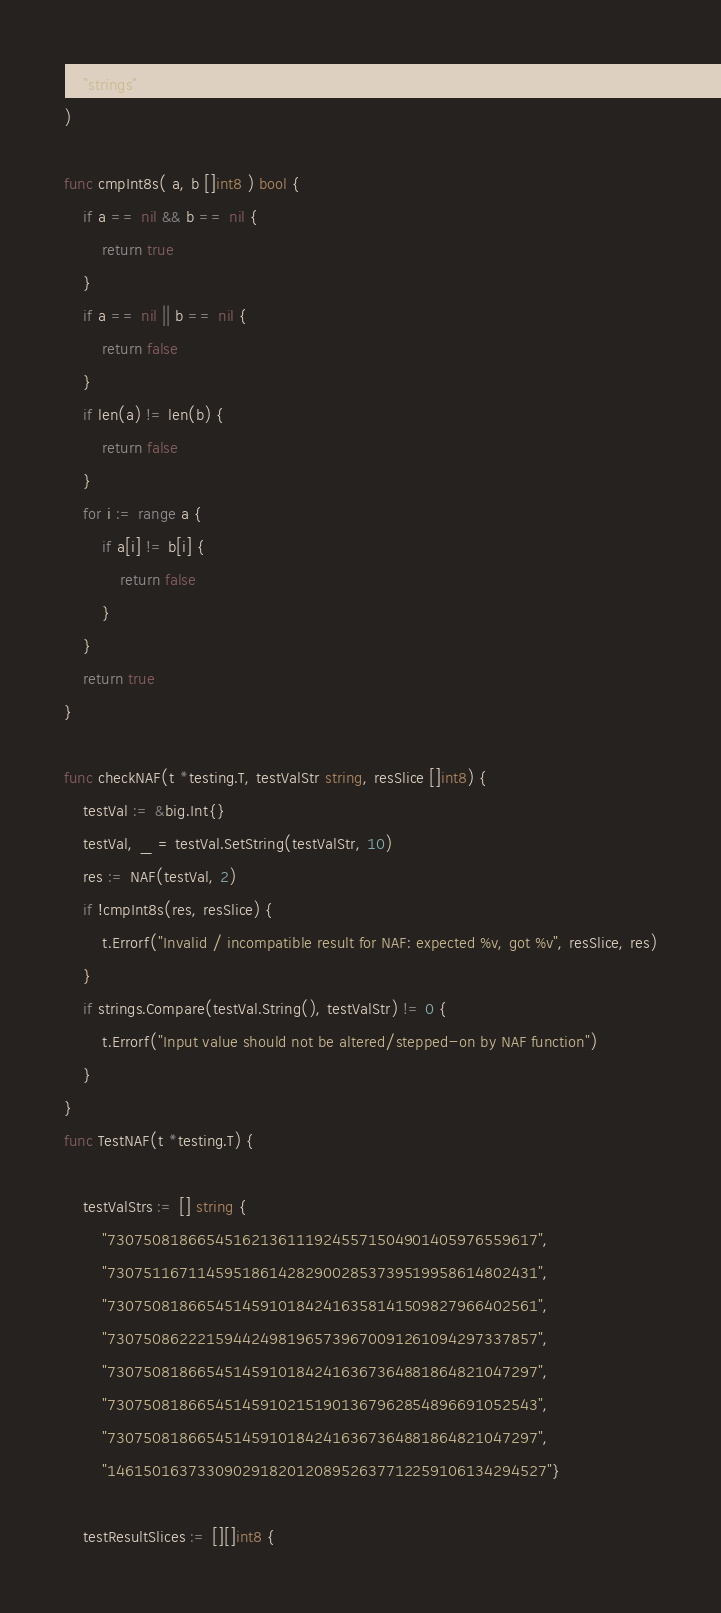Convert code to text. <code><loc_0><loc_0><loc_500><loc_500><_Go_>	"strings"
)

func cmpInt8s( a, b []int8 ) bool {
	if a == nil && b == nil {
		return true
	}
	if a == nil || b == nil {
		return false
	}
	if len(a) != len(b) {
		return false
	}
	for i := range a {
		if a[i] != b[i] {
			return false
		}
	}
	return true
}

func checkNAF(t *testing.T, testValStr string, resSlice []int8) {
	testVal := &big.Int{}
	testVal, _ = testVal.SetString(testValStr, 10)
	res := NAF(testVal, 2)
	if !cmpInt8s(res, resSlice) {
		t.Errorf("Invalid / incompatible result for NAF: expected %v, got %v", resSlice, res)
	}
	if strings.Compare(testVal.String(), testValStr) != 0 {
		t.Errorf("Input value should not be altered/stepped-on by NAF function")
	}
}
func TestNAF(t *testing.T) {

	testValStrs := [] string {
		"730750818665451621361119245571504901405976559617",
		"730751167114595186142829002853739519958614802431",
		"730750818665451459101842416358141509827966402561",
		"730750862221594424981965739670091261094297337857",
		"730750818665451459101842416367364881864821047297",
		"730750818665451459102151901367962854896691052543",
		"730750818665451459101842416367364881864821047297",
		"1461501637330902918201208952637712259106134294527"}

	testResultSlices := [][]int8 {</code> 